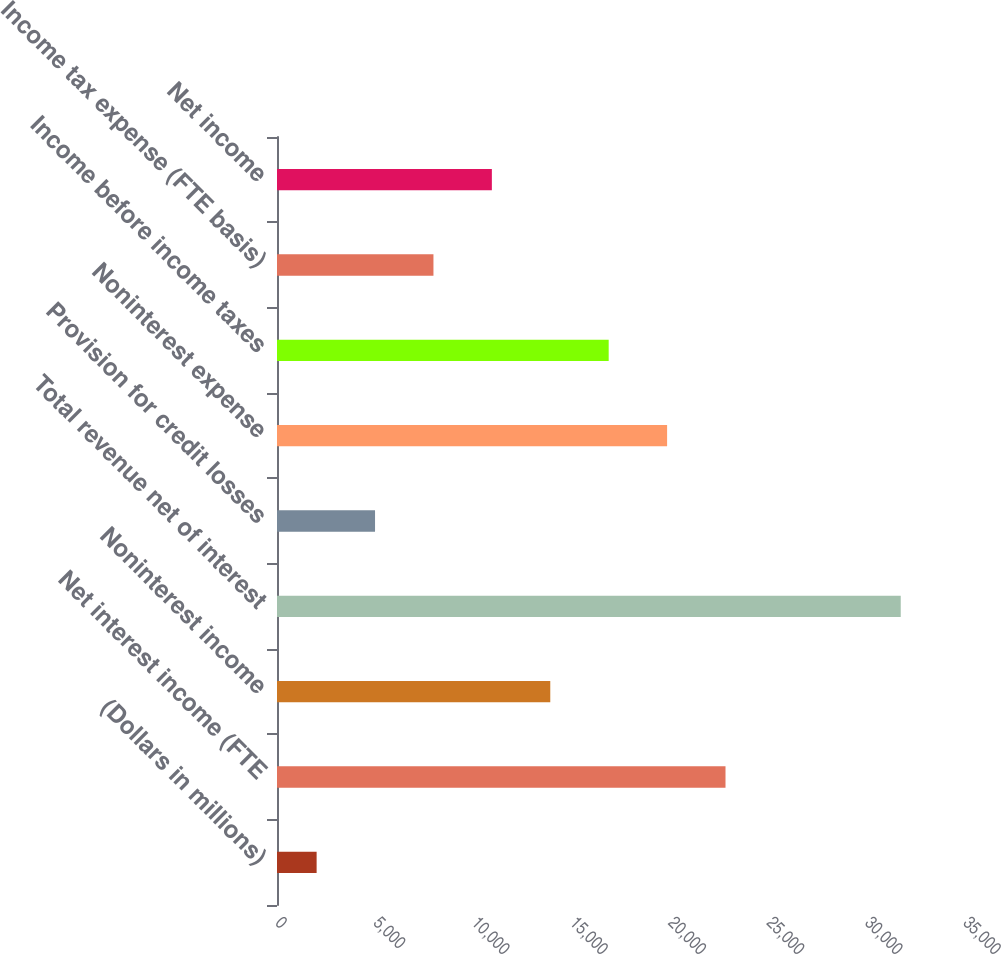Convert chart to OTSL. <chart><loc_0><loc_0><loc_500><loc_500><bar_chart><fcel>(Dollars in millions)<fcel>Net interest income (FTE<fcel>Noninterest income<fcel>Total revenue net of interest<fcel>Provision for credit losses<fcel>Noninterest expense<fcel>Income before income taxes<fcel>Income tax expense (FTE basis)<fcel>Net income<nl><fcel>2016<fcel>22816.5<fcel>13902<fcel>31731<fcel>4987.5<fcel>19845<fcel>16873.5<fcel>7959<fcel>10930.5<nl></chart> 